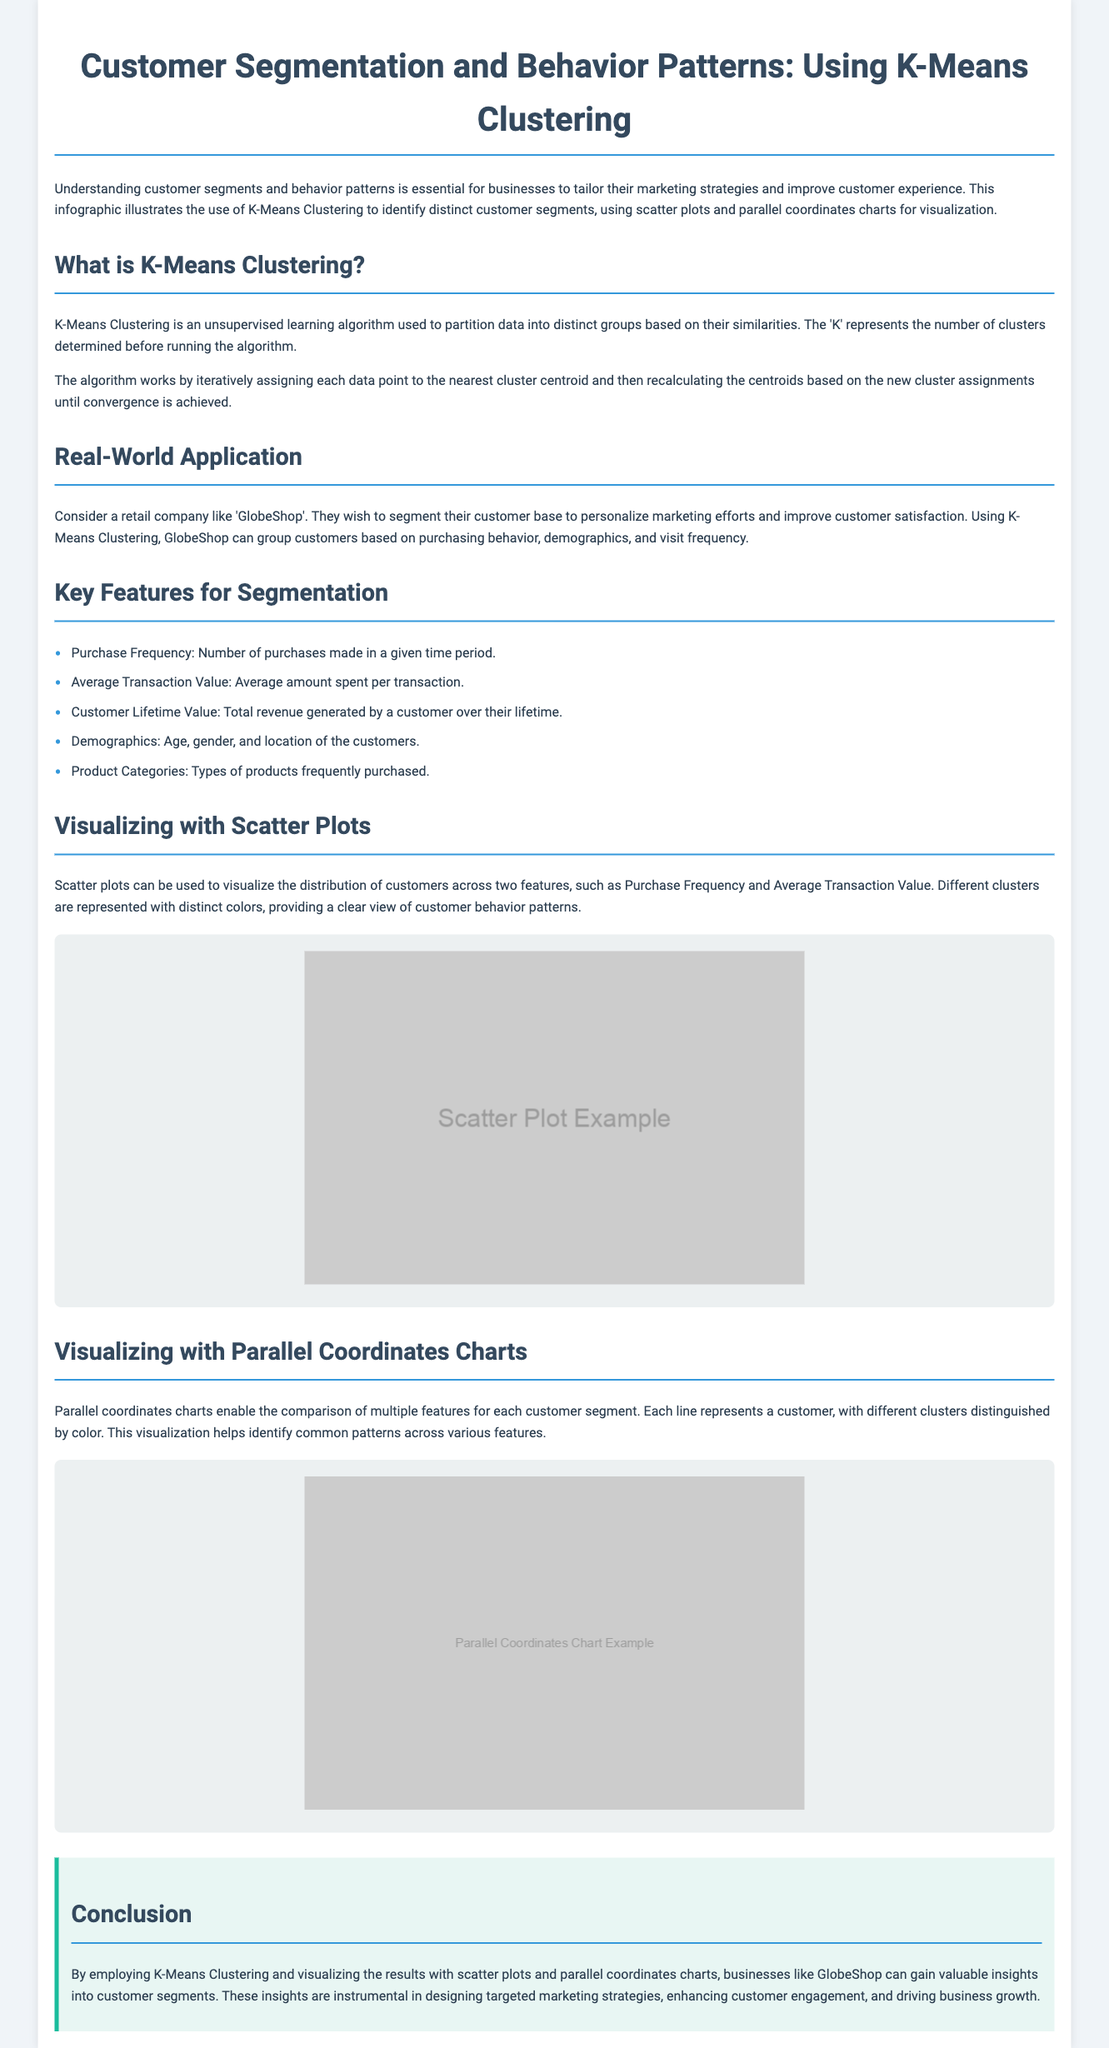what is K-Means Clustering? K-Means Clustering is an unsupervised learning algorithm used to partition data into distinct groups based on their similarities.
Answer: unsupervised learning algorithm what retail company is used as an example? The document mentions a retail company named 'GlobeShop' as an example for segmentation.
Answer: GlobeShop how many key features for segmentation are listed? The document lists five key features for segmentation.
Answer: five what types of charts are used for visualizing customer segments? The document states that scatter plots and parallel coordinates charts are used for visualization.
Answer: scatter plots and parallel coordinates charts what feature involves the total revenue generated by a customer? The feature that involves the total revenue is known as Customer Lifetime Value.
Answer: Customer Lifetime Value what does the scatter plot visualize? The scatter plot visualizes the distribution of customers across two features, such as Purchase Frequency and Average Transaction Value.
Answer: distribution of customers what purpose does the conclusion emphasize? The conclusion highlights the importance of gaining insights into customer segments for targeted marketing strategies.
Answer: targeted marketing strategies how are different clusters represented in the scatter plot? Different clusters in the scatter plot are represented with distinct colors.
Answer: distinct colors how does a parallel coordinates chart help in customer behavior analysis? A parallel coordinates chart helps identify common patterns across various features for each customer segment.
Answer: identify common patterns 